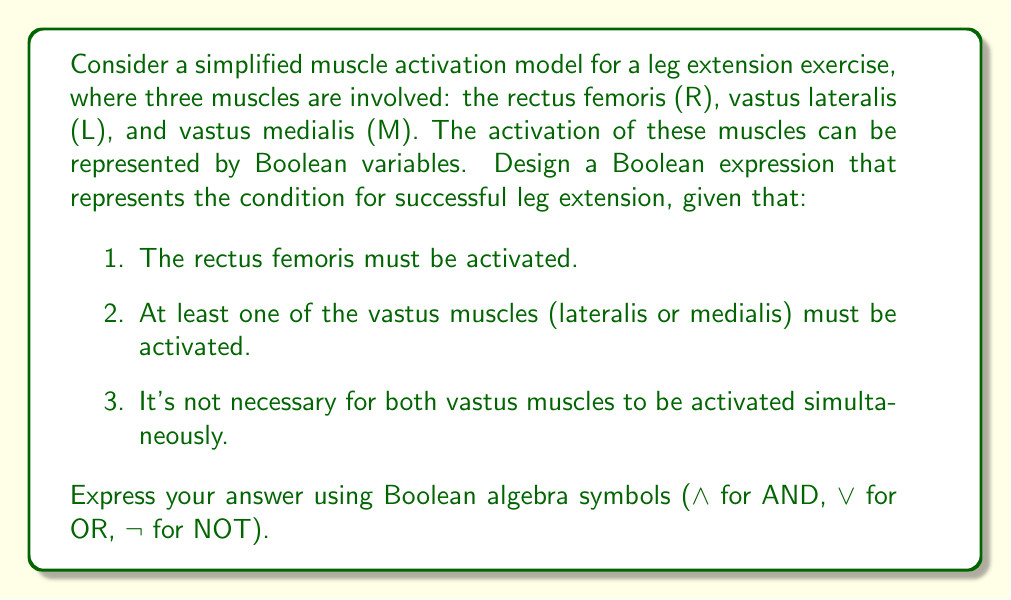Show me your answer to this math problem. To solve this problem, we need to translate the given conditions into Boolean expressions and combine them logically:

1. The rectus femoris must be activated: This is simply represented by R.

2. At least one of the vastus muscles must be activated: This can be expressed as (L ∨ M).

3. It's not necessary for both vastus muscles to be activated simultaneously: This condition is already satisfied by (L ∨ M), as it allows for either one or both to be true.

Combining these conditions:

1. R must be true AND
2. (L ∨ M) must be true

Therefore, the Boolean expression for successful leg extension is:

$$ R ∧ (L ∨ M) $$

This expression ensures that:
- The rectus femoris is always activated (R is true)
- At least one of the vastus muscles is activated (either L or M or both are true)

We can verify this by considering the truth table:

| R | L | M | R ∧ (L ∨ M) |
|---|---|---|-------------|
| 0 | 0 | 0 |     0       |
| 0 | 0 | 1 |     0       |
| 0 | 1 | 0 |     0       |
| 0 | 1 | 1 |     0       |
| 1 | 0 | 0 |     0       |
| 1 | 0 | 1 |     1       |
| 1 | 1 | 0 |     1       |
| 1 | 1 | 1 |     1       |

The expression is true (1) only when R is true and at least one of L or M is true, which satisfies all our conditions for successful leg extension.
Answer: $$ R ∧ (L ∨ M) $$ 